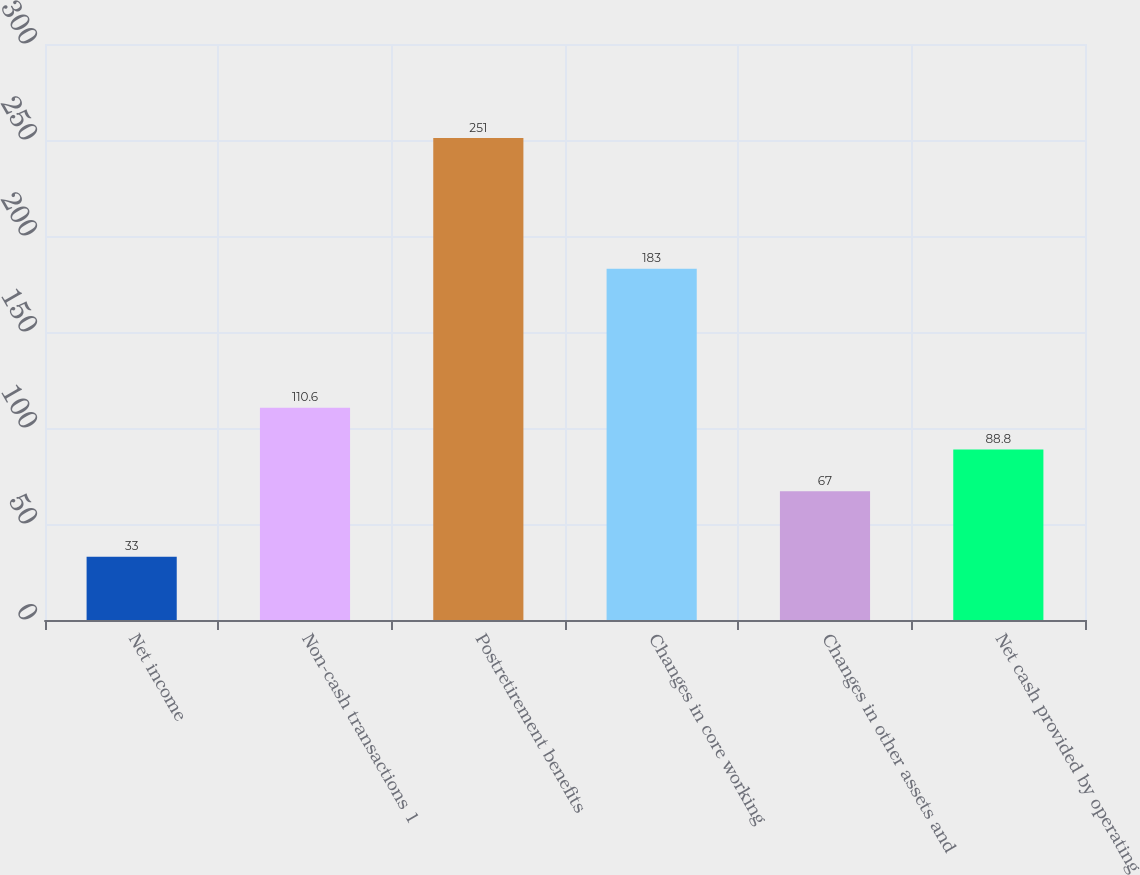Convert chart to OTSL. <chart><loc_0><loc_0><loc_500><loc_500><bar_chart><fcel>Net income<fcel>Non-cash transactions 1<fcel>Postretirement benefits<fcel>Changes in core working<fcel>Changes in other assets and<fcel>Net cash provided by operating<nl><fcel>33<fcel>110.6<fcel>251<fcel>183<fcel>67<fcel>88.8<nl></chart> 